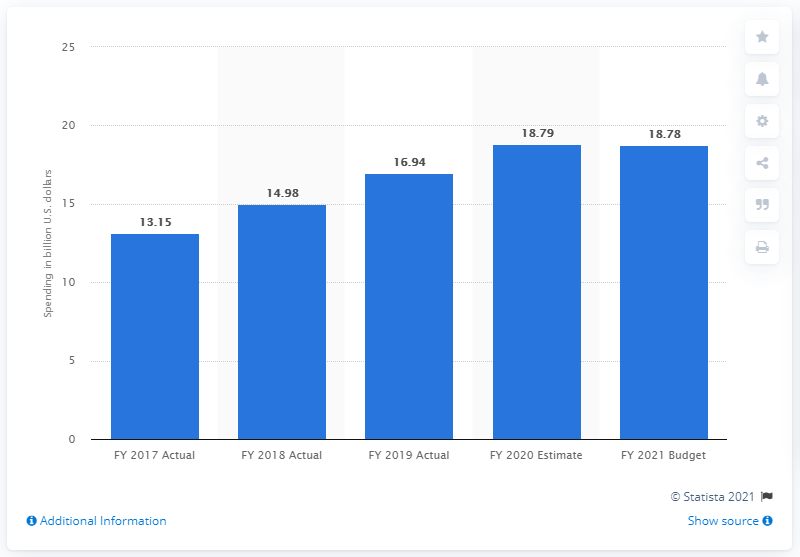Draw attention to some important aspects in this diagram. The proposed amount for cyber security funding by the U.S. government for FY 2021 is 18.79. 